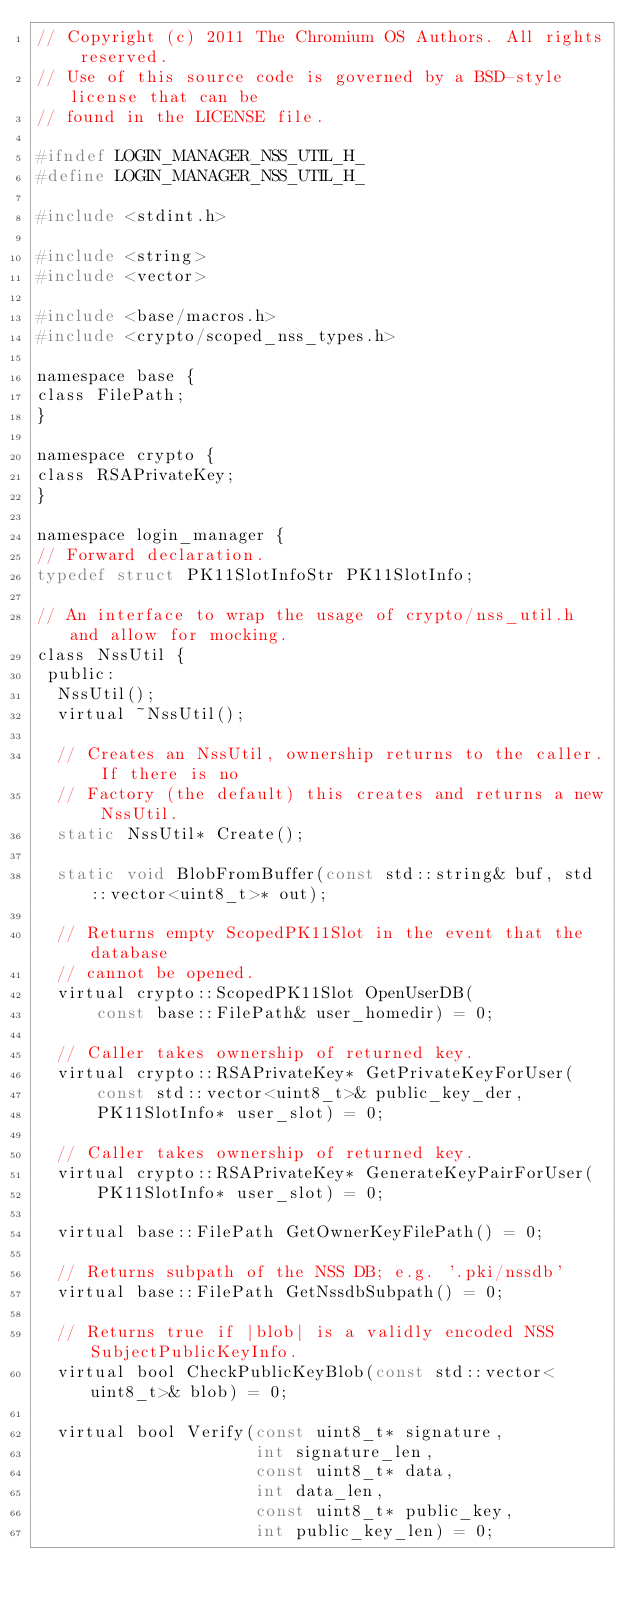<code> <loc_0><loc_0><loc_500><loc_500><_C_>// Copyright (c) 2011 The Chromium OS Authors. All rights reserved.
// Use of this source code is governed by a BSD-style license that can be
// found in the LICENSE file.

#ifndef LOGIN_MANAGER_NSS_UTIL_H_
#define LOGIN_MANAGER_NSS_UTIL_H_

#include <stdint.h>

#include <string>
#include <vector>

#include <base/macros.h>
#include <crypto/scoped_nss_types.h>

namespace base {
class FilePath;
}

namespace crypto {
class RSAPrivateKey;
}

namespace login_manager {
// Forward declaration.
typedef struct PK11SlotInfoStr PK11SlotInfo;

// An interface to wrap the usage of crypto/nss_util.h and allow for mocking.
class NssUtil {
 public:
  NssUtil();
  virtual ~NssUtil();

  // Creates an NssUtil, ownership returns to the caller. If there is no
  // Factory (the default) this creates and returns a new NssUtil.
  static NssUtil* Create();

  static void BlobFromBuffer(const std::string& buf, std::vector<uint8_t>* out);

  // Returns empty ScopedPK11Slot in the event that the database
  // cannot be opened.
  virtual crypto::ScopedPK11Slot OpenUserDB(
      const base::FilePath& user_homedir) = 0;

  // Caller takes ownership of returned key.
  virtual crypto::RSAPrivateKey* GetPrivateKeyForUser(
      const std::vector<uint8_t>& public_key_der,
      PK11SlotInfo* user_slot) = 0;

  // Caller takes ownership of returned key.
  virtual crypto::RSAPrivateKey* GenerateKeyPairForUser(
      PK11SlotInfo* user_slot) = 0;

  virtual base::FilePath GetOwnerKeyFilePath() = 0;

  // Returns subpath of the NSS DB; e.g. '.pki/nssdb'
  virtual base::FilePath GetNssdbSubpath() = 0;

  // Returns true if |blob| is a validly encoded NSS SubjectPublicKeyInfo.
  virtual bool CheckPublicKeyBlob(const std::vector<uint8_t>& blob) = 0;

  virtual bool Verify(const uint8_t* signature,
                      int signature_len,
                      const uint8_t* data,
                      int data_len,
                      const uint8_t* public_key,
                      int public_key_len) = 0;
</code> 